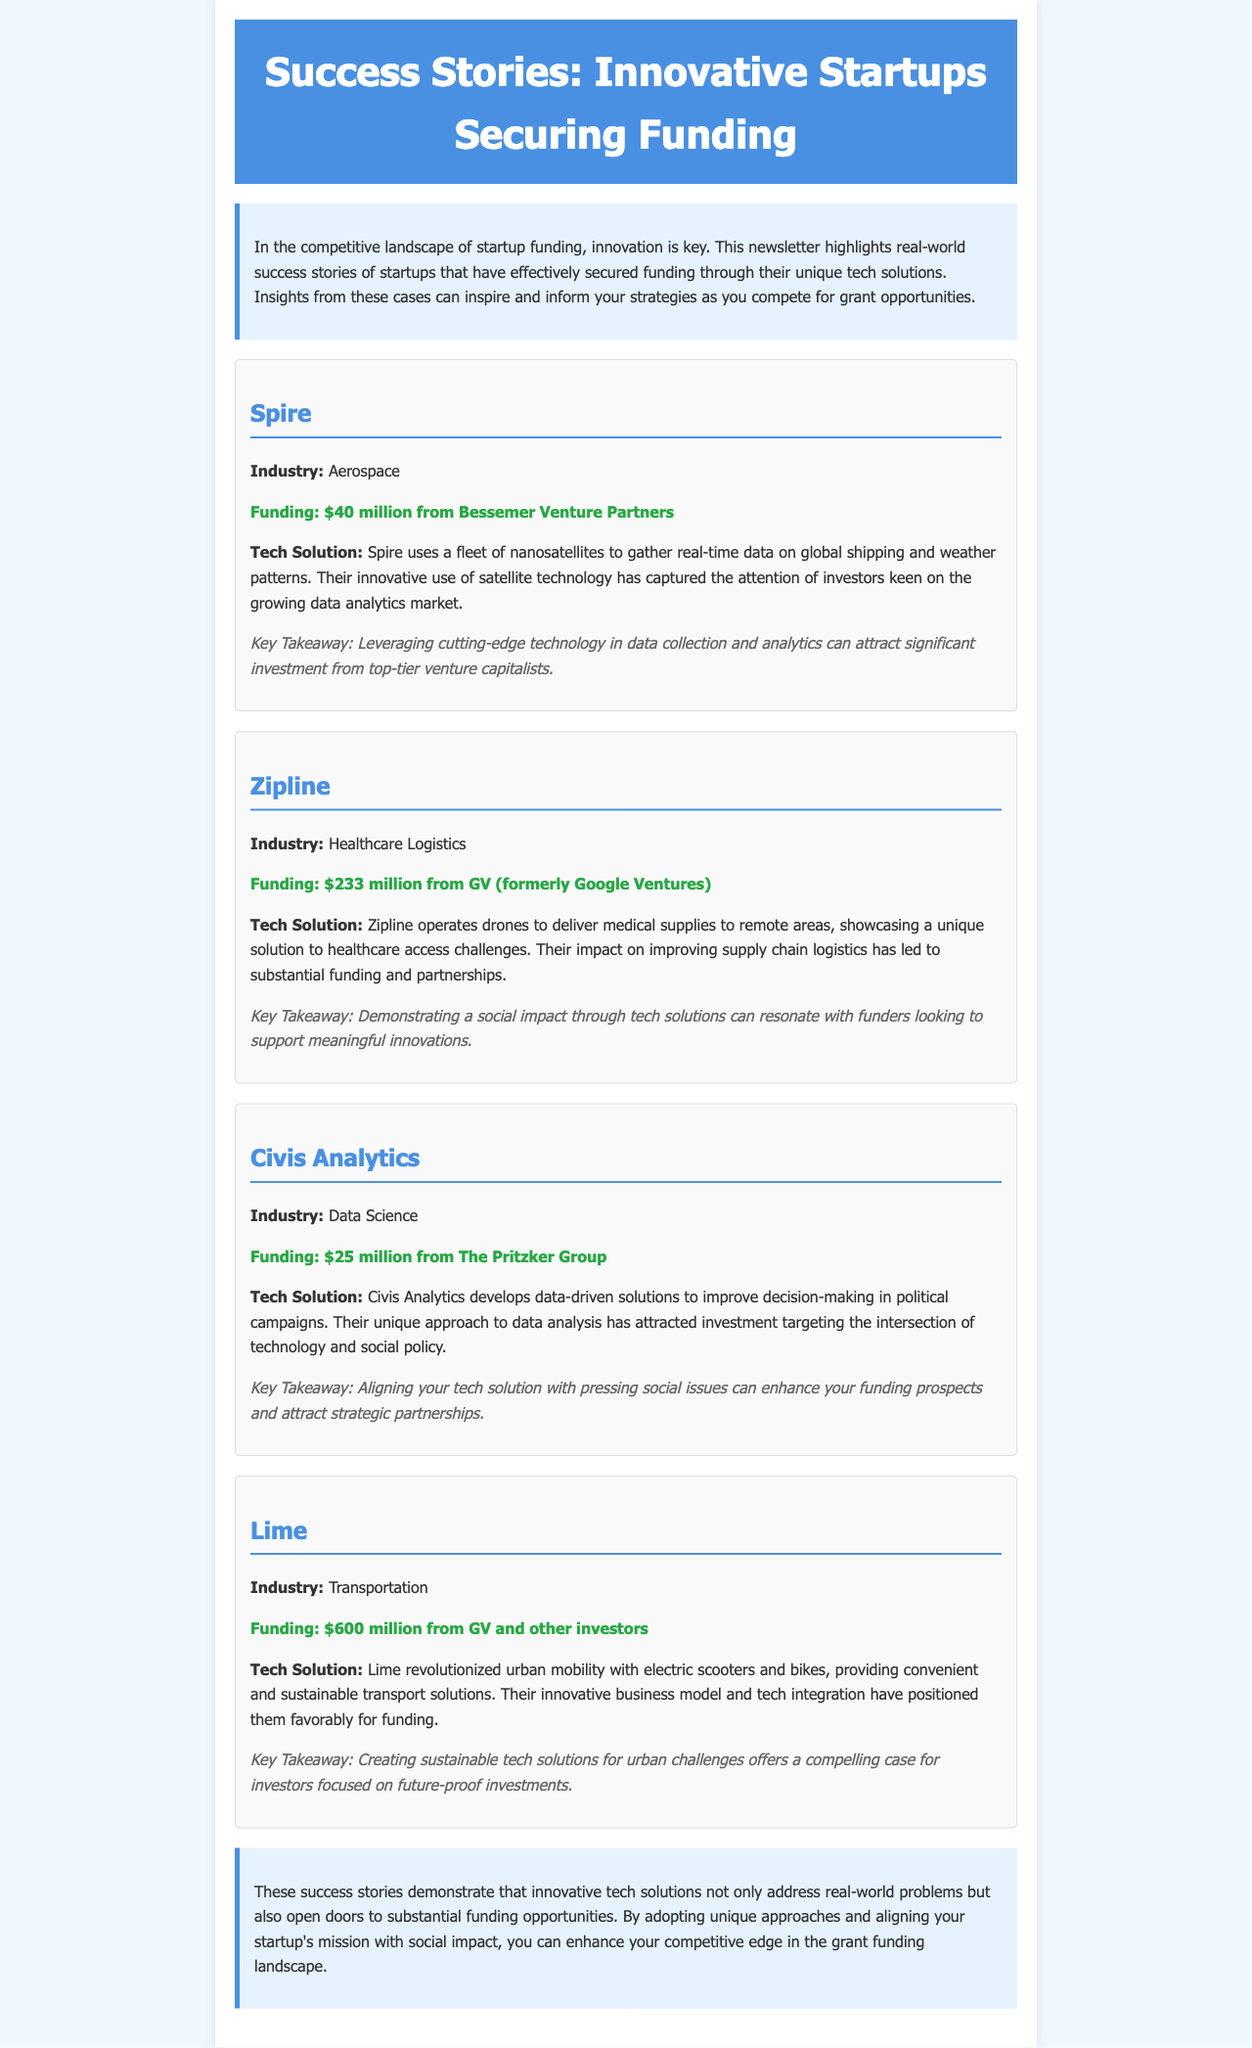What is the funding amount of Spire? The funding amount for Spire is highlighted in the success story section.
Answer: $40 million What innovative solution does Zipline provide? This information is located in the description of Zipline's tech solution in the newsletter.
Answer: Drones for delivering medical supplies How much funding did Lime secure? The funding amount for Lime is specified in the success story section.
Answer: $600 million What is the key takeaway from Civis Analytics' story? The key takeaway is mentioned under the Civis Analytics section as a critical insight.
Answer: Aligning your tech solution with pressing social issues Which industry does Lime operate in? The industry for Lime is stated in the success story section.
Answer: Transportation Which venture capital firm funded Civis Analytics? This detail is included in the funding information of the Civis Analytics story.
Answer: The Pritzker Group How does Spire collect data? The method of data collection for Spire is described in their tech solution section.
Answer: Nanosatellites What social impact does Zipline's technology address? This is discussed in the description of Zipline, indicating what issues their solutions target.
Answer: Healthcare access challenges 